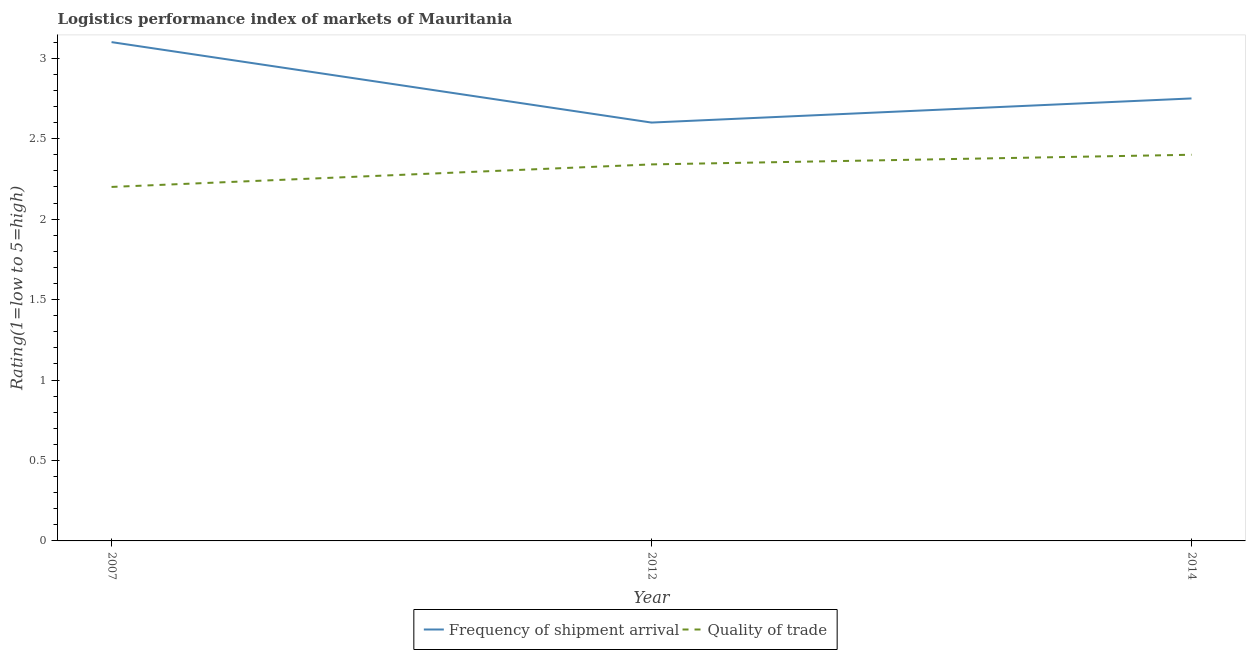Does the line corresponding to lpi quality of trade intersect with the line corresponding to lpi of frequency of shipment arrival?
Offer a very short reply. No. Is the number of lines equal to the number of legend labels?
Your answer should be very brief. Yes. Across all years, what is the minimum lpi of frequency of shipment arrival?
Your answer should be very brief. 2.6. In which year was the lpi quality of trade maximum?
Keep it short and to the point. 2014. What is the total lpi of frequency of shipment arrival in the graph?
Keep it short and to the point. 8.45. What is the difference between the lpi of frequency of shipment arrival in 2007 and that in 2012?
Give a very brief answer. 0.5. What is the difference between the lpi of frequency of shipment arrival in 2007 and the lpi quality of trade in 2014?
Offer a terse response. 0.7. What is the average lpi quality of trade per year?
Ensure brevity in your answer.  2.31. In the year 2007, what is the difference between the lpi quality of trade and lpi of frequency of shipment arrival?
Offer a very short reply. -0.9. In how many years, is the lpi of frequency of shipment arrival greater than 2.1?
Your answer should be very brief. 3. What is the ratio of the lpi of frequency of shipment arrival in 2007 to that in 2012?
Offer a very short reply. 1.19. Is the difference between the lpi quality of trade in 2007 and 2014 greater than the difference between the lpi of frequency of shipment arrival in 2007 and 2014?
Keep it short and to the point. No. What is the difference between the highest and the second highest lpi quality of trade?
Provide a short and direct response. 0.06. In how many years, is the lpi quality of trade greater than the average lpi quality of trade taken over all years?
Provide a short and direct response. 2. Is the lpi quality of trade strictly greater than the lpi of frequency of shipment arrival over the years?
Provide a short and direct response. No. Is the lpi quality of trade strictly less than the lpi of frequency of shipment arrival over the years?
Offer a terse response. Yes. How many lines are there?
Give a very brief answer. 2. How many years are there in the graph?
Offer a very short reply. 3. Does the graph contain any zero values?
Give a very brief answer. No. Does the graph contain grids?
Give a very brief answer. No. Where does the legend appear in the graph?
Provide a short and direct response. Bottom center. What is the title of the graph?
Keep it short and to the point. Logistics performance index of markets of Mauritania. What is the label or title of the Y-axis?
Keep it short and to the point. Rating(1=low to 5=high). What is the Rating(1=low to 5=high) in Quality of trade in 2007?
Give a very brief answer. 2.2. What is the Rating(1=low to 5=high) in Frequency of shipment arrival in 2012?
Provide a succinct answer. 2.6. What is the Rating(1=low to 5=high) in Quality of trade in 2012?
Offer a very short reply. 2.34. What is the Rating(1=low to 5=high) of Frequency of shipment arrival in 2014?
Ensure brevity in your answer.  2.75. What is the Rating(1=low to 5=high) in Quality of trade in 2014?
Give a very brief answer. 2.4. Across all years, what is the minimum Rating(1=low to 5=high) in Quality of trade?
Give a very brief answer. 2.2. What is the total Rating(1=low to 5=high) in Frequency of shipment arrival in the graph?
Give a very brief answer. 8.45. What is the total Rating(1=low to 5=high) of Quality of trade in the graph?
Give a very brief answer. 6.94. What is the difference between the Rating(1=low to 5=high) in Frequency of shipment arrival in 2007 and that in 2012?
Make the answer very short. 0.5. What is the difference between the Rating(1=low to 5=high) in Quality of trade in 2007 and that in 2012?
Your response must be concise. -0.14. What is the difference between the Rating(1=low to 5=high) in Quality of trade in 2007 and that in 2014?
Provide a short and direct response. -0.2. What is the difference between the Rating(1=low to 5=high) in Quality of trade in 2012 and that in 2014?
Ensure brevity in your answer.  -0.06. What is the difference between the Rating(1=low to 5=high) in Frequency of shipment arrival in 2007 and the Rating(1=low to 5=high) in Quality of trade in 2012?
Offer a very short reply. 0.76. What is the difference between the Rating(1=low to 5=high) in Frequency of shipment arrival in 2012 and the Rating(1=low to 5=high) in Quality of trade in 2014?
Give a very brief answer. 0.2. What is the average Rating(1=low to 5=high) of Frequency of shipment arrival per year?
Provide a short and direct response. 2.82. What is the average Rating(1=low to 5=high) of Quality of trade per year?
Give a very brief answer. 2.31. In the year 2012, what is the difference between the Rating(1=low to 5=high) of Frequency of shipment arrival and Rating(1=low to 5=high) of Quality of trade?
Offer a very short reply. 0.26. What is the ratio of the Rating(1=low to 5=high) in Frequency of shipment arrival in 2007 to that in 2012?
Your answer should be compact. 1.19. What is the ratio of the Rating(1=low to 5=high) of Quality of trade in 2007 to that in 2012?
Your response must be concise. 0.94. What is the ratio of the Rating(1=low to 5=high) in Frequency of shipment arrival in 2007 to that in 2014?
Your answer should be very brief. 1.13. What is the ratio of the Rating(1=low to 5=high) in Frequency of shipment arrival in 2012 to that in 2014?
Offer a terse response. 0.95. What is the ratio of the Rating(1=low to 5=high) of Quality of trade in 2012 to that in 2014?
Ensure brevity in your answer.  0.97. What is the difference between the highest and the second highest Rating(1=low to 5=high) in Frequency of shipment arrival?
Make the answer very short. 0.35. What is the difference between the highest and the second highest Rating(1=low to 5=high) in Quality of trade?
Offer a very short reply. 0.06. 